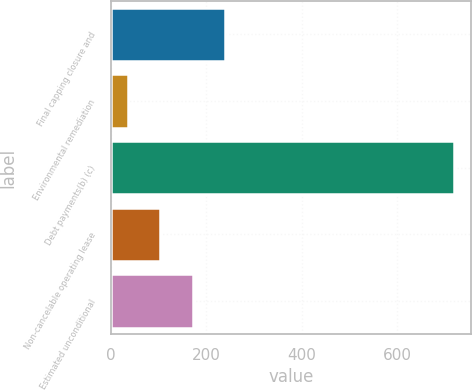Convert chart to OTSL. <chart><loc_0><loc_0><loc_500><loc_500><bar_chart><fcel>Final capping closure and<fcel>Environmental remediation<fcel>Debt payments(b) (c)<fcel>Non-cancelable operating lease<fcel>Estimated unconditional<nl><fcel>240.2<fcel>35<fcel>719<fcel>103.4<fcel>171.8<nl></chart> 